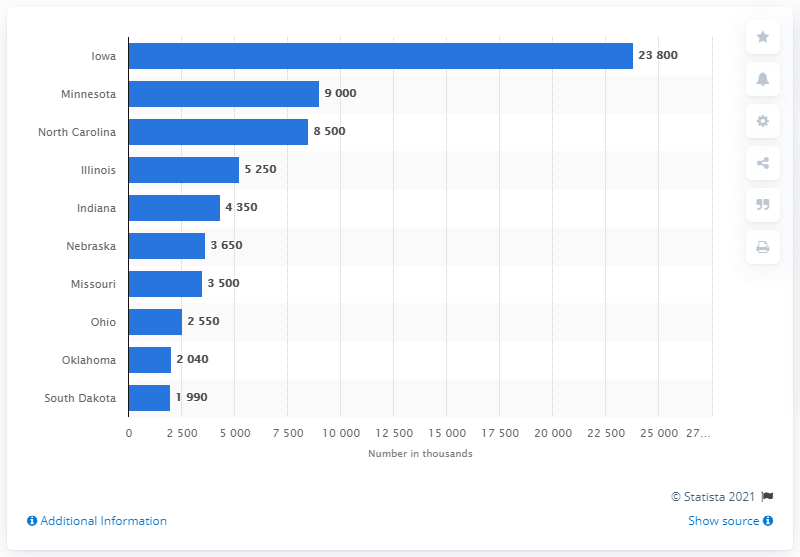Outline some significant characteristics in this image. In 2021, Minnesota was the second largest producer of hogs and pigs in the United States. 